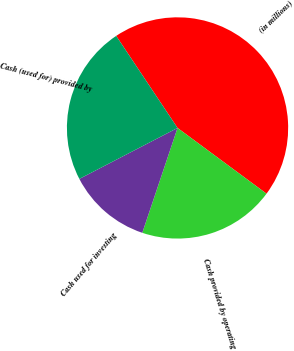Convert chart. <chart><loc_0><loc_0><loc_500><loc_500><pie_chart><fcel>(in millions)<fcel>Cash provided by operating<fcel>Cash used for investing<fcel>Cash (used for) provided by<nl><fcel>44.48%<fcel>20.03%<fcel>12.22%<fcel>23.26%<nl></chart> 